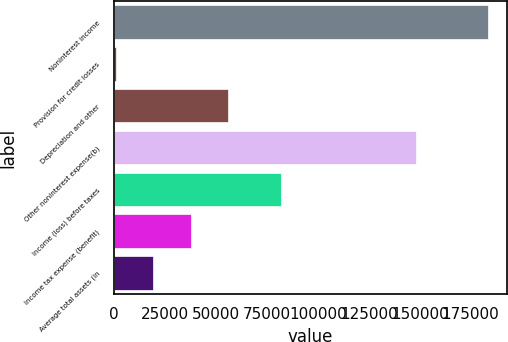<chart> <loc_0><loc_0><loc_500><loc_500><bar_chart><fcel>Noninterest income<fcel>Provision for credit losses<fcel>Depreciation and other<fcel>Other noninterest expense(b)<fcel>Income (loss) before taxes<fcel>Income tax expense (benefit)<fcel>Average total assets (in<nl><fcel>183677<fcel>953<fcel>55770.2<fcel>148432<fcel>81787<fcel>37497.8<fcel>19225.4<nl></chart> 